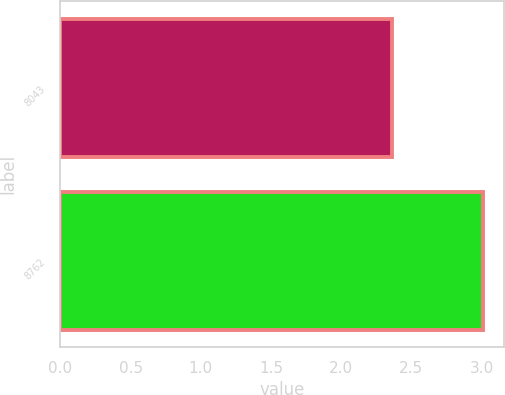Convert chart to OTSL. <chart><loc_0><loc_0><loc_500><loc_500><bar_chart><fcel>8043<fcel>8762<nl><fcel>2.36<fcel>3.01<nl></chart> 